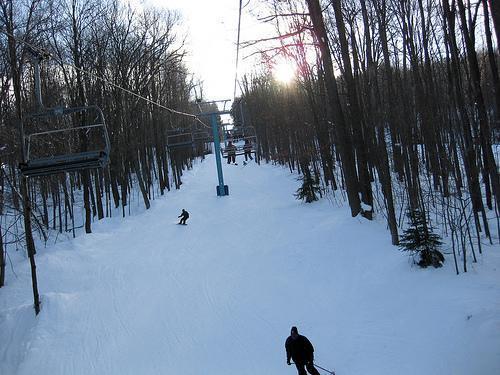How many people are skiing?
Give a very brief answer. 2. How many people are riding the ski lift?
Give a very brief answer. 2. How many people are not on the lift?
Give a very brief answer. 2. 